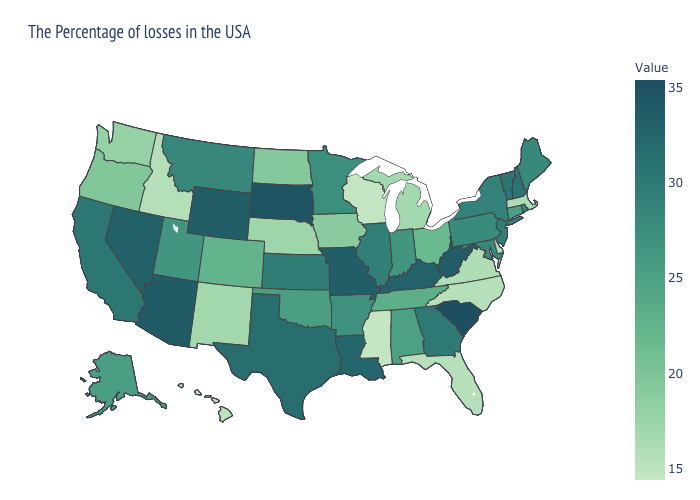Which states have the lowest value in the Northeast?
Be succinct. Massachusetts. Which states have the lowest value in the USA?
Answer briefly. Mississippi. Which states have the highest value in the USA?
Keep it brief. South Carolina. Which states have the highest value in the USA?
Answer briefly. South Carolina. Among the states that border Maryland , does Delaware have the lowest value?
Keep it brief. Yes. Does Colorado have a higher value than Illinois?
Keep it brief. No. 